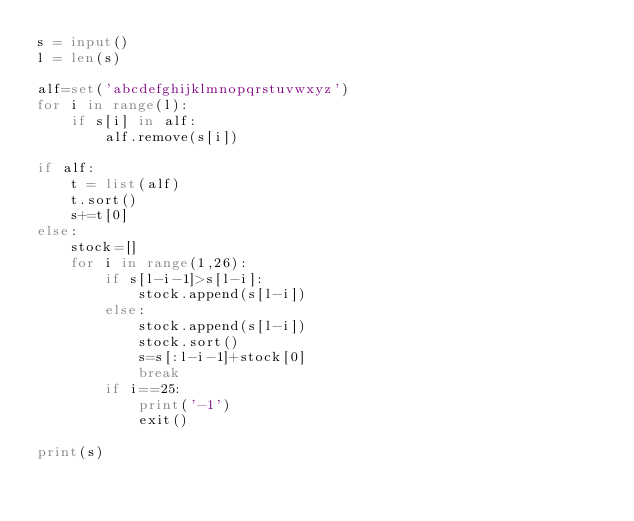<code> <loc_0><loc_0><loc_500><loc_500><_Python_>s = input()
l = len(s)

alf=set('abcdefghijklmnopqrstuvwxyz')
for i in range(l):
    if s[i] in alf:
        alf.remove(s[i])

if alf:
    t = list(alf)
    t.sort()
    s+=t[0]
else:
    stock=[]
    for i in range(1,26):
        if s[l-i-1]>s[l-i]:
            stock.append(s[l-i])
        else:
            stock.append(s[l-i])
            stock.sort()
            s=s[:l-i-1]+stock[0]
            break
        if i==25:
            print('-1')
            exit()

print(s)
</code> 